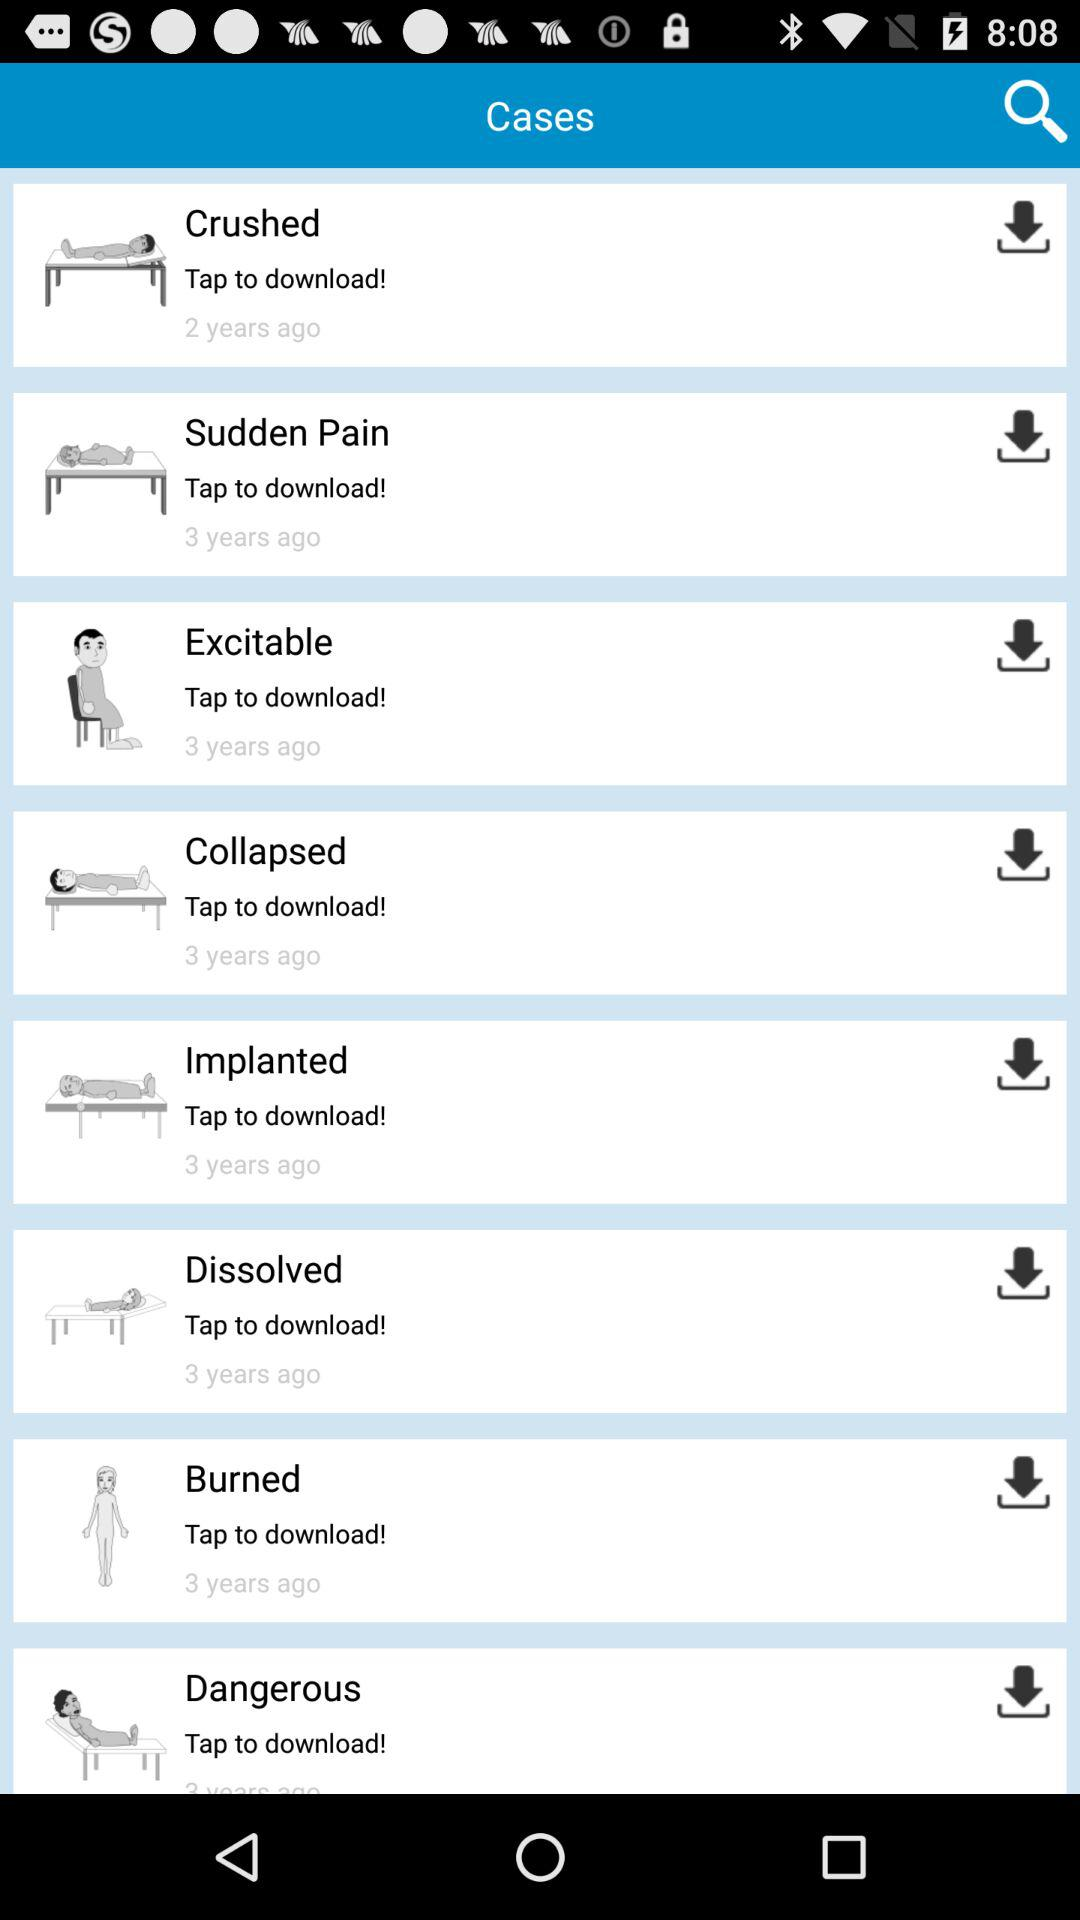How many years ago was "Sudden Pain" published? The "Sudden Pain" was published 3 years ago. 